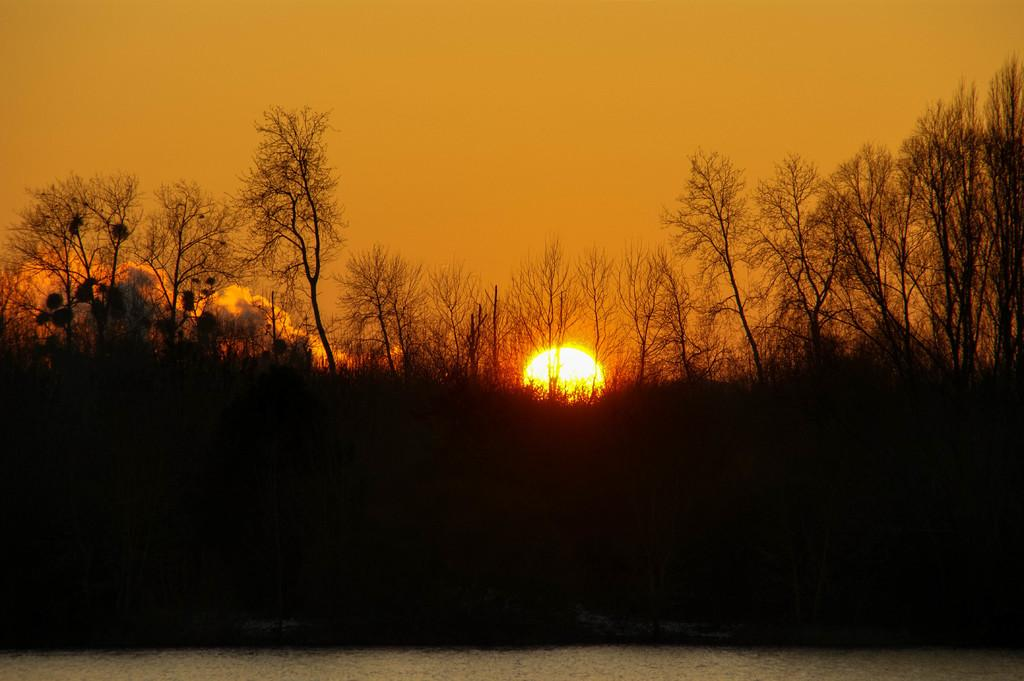What type of vegetation can be seen in the image? There are trees in the image. What time of day is depicted in the image? The image depicts a sunset. What can be seen in the background of the image? The sky is visible in the background of the image. What type of beef is being served in the image? There is no beef present in the image; it features trees and a sunset. What body part is visible in the image? There are no body parts visible in the image; it features trees and a sunset. 